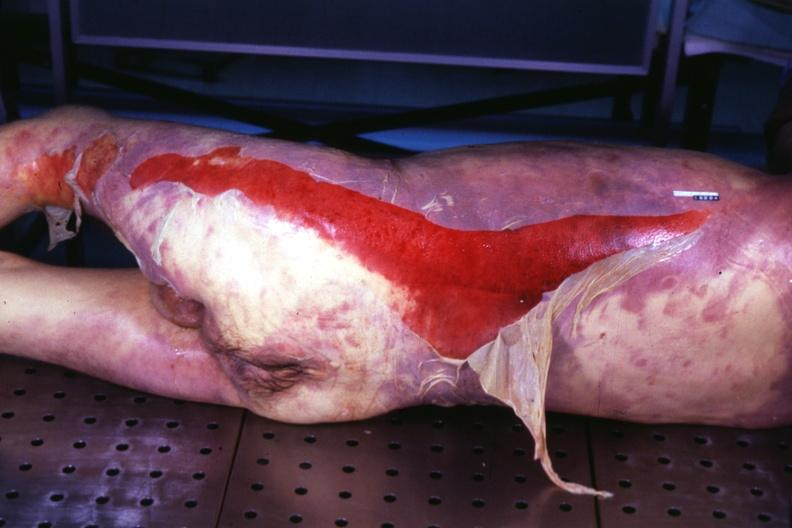s this photo present?
Answer the question using a single word or phrase. No 